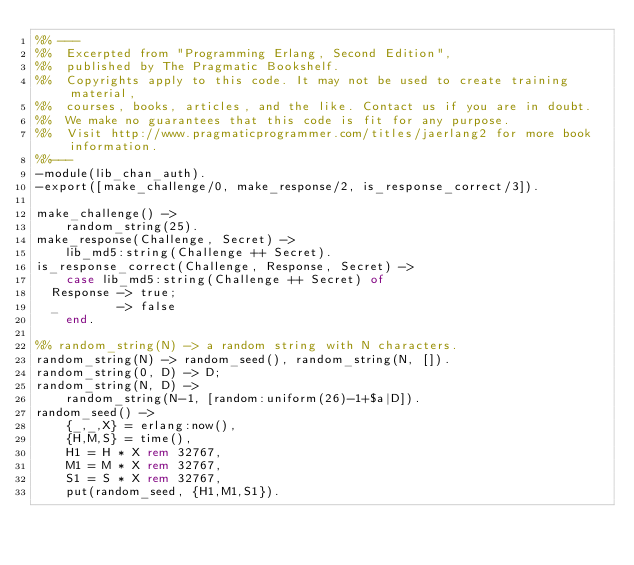<code> <loc_0><loc_0><loc_500><loc_500><_Erlang_>%% ---
%%  Excerpted from "Programming Erlang, Second Edition",
%%  published by The Pragmatic Bookshelf.
%%  Copyrights apply to this code. It may not be used to create training material, 
%%  courses, books, articles, and the like. Contact us if you are in doubt.
%%  We make no guarantees that this code is fit for any purpose. 
%%  Visit http://www.pragmaticprogrammer.com/titles/jaerlang2 for more book information.
%%---
-module(lib_chan_auth).
-export([make_challenge/0, make_response/2, is_response_correct/3]).

make_challenge() ->
    random_string(25).
make_response(Challenge, Secret) ->
    lib_md5:string(Challenge ++ Secret).
is_response_correct(Challenge, Response, Secret) ->
    case lib_md5:string(Challenge ++ Secret) of
	Response -> true;
	_        -> false
    end.

%% random_string(N) -> a random string with N characters.
random_string(N) -> random_seed(), random_string(N, []).
random_string(0, D) -> D;
random_string(N, D) ->
    random_string(N-1, [random:uniform(26)-1+$a|D]).
random_seed() ->
    {_,_,X} = erlang:now(),
    {H,M,S} = time(),
    H1 = H * X rem 32767,
    M1 = M * X rem 32767,
    S1 = S * X rem 32767,
    put(random_seed, {H1,M1,S1}).</code> 